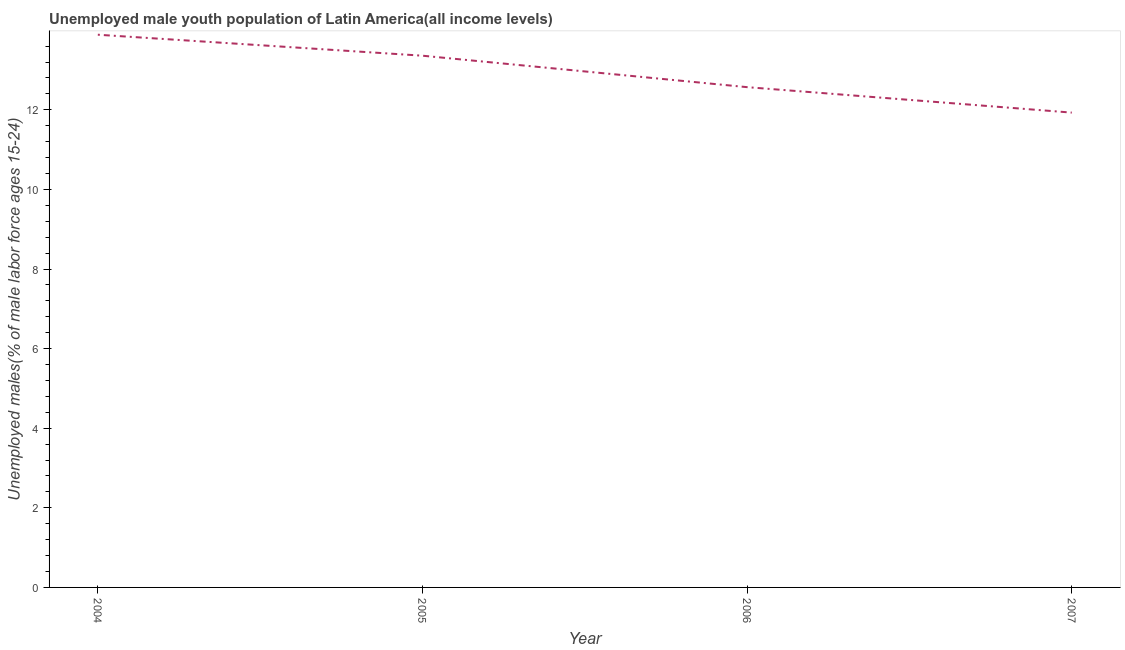What is the unemployed male youth in 2005?
Your answer should be very brief. 13.36. Across all years, what is the maximum unemployed male youth?
Your response must be concise. 13.89. Across all years, what is the minimum unemployed male youth?
Make the answer very short. 11.93. In which year was the unemployed male youth maximum?
Keep it short and to the point. 2004. What is the sum of the unemployed male youth?
Your answer should be compact. 51.74. What is the difference between the unemployed male youth in 2004 and 2007?
Ensure brevity in your answer.  1.96. What is the average unemployed male youth per year?
Your answer should be very brief. 12.94. What is the median unemployed male youth?
Offer a terse response. 12.96. Do a majority of the years between 2005 and 2007 (inclusive) have unemployed male youth greater than 1.6 %?
Your answer should be very brief. Yes. What is the ratio of the unemployed male youth in 2004 to that in 2006?
Ensure brevity in your answer.  1.1. Is the difference between the unemployed male youth in 2004 and 2007 greater than the difference between any two years?
Your answer should be compact. Yes. What is the difference between the highest and the second highest unemployed male youth?
Provide a succinct answer. 0.53. What is the difference between the highest and the lowest unemployed male youth?
Offer a very short reply. 1.96. In how many years, is the unemployed male youth greater than the average unemployed male youth taken over all years?
Offer a very short reply. 2. Does the unemployed male youth monotonically increase over the years?
Provide a short and direct response. No. How many lines are there?
Offer a very short reply. 1. How many years are there in the graph?
Your answer should be compact. 4. What is the difference between two consecutive major ticks on the Y-axis?
Give a very brief answer. 2. Does the graph contain any zero values?
Ensure brevity in your answer.  No. What is the title of the graph?
Offer a terse response. Unemployed male youth population of Latin America(all income levels). What is the label or title of the X-axis?
Your response must be concise. Year. What is the label or title of the Y-axis?
Keep it short and to the point. Unemployed males(% of male labor force ages 15-24). What is the Unemployed males(% of male labor force ages 15-24) in 2004?
Ensure brevity in your answer.  13.89. What is the Unemployed males(% of male labor force ages 15-24) of 2005?
Give a very brief answer. 13.36. What is the Unemployed males(% of male labor force ages 15-24) in 2006?
Provide a short and direct response. 12.57. What is the Unemployed males(% of male labor force ages 15-24) in 2007?
Your answer should be compact. 11.93. What is the difference between the Unemployed males(% of male labor force ages 15-24) in 2004 and 2005?
Your answer should be very brief. 0.53. What is the difference between the Unemployed males(% of male labor force ages 15-24) in 2004 and 2006?
Provide a short and direct response. 1.32. What is the difference between the Unemployed males(% of male labor force ages 15-24) in 2004 and 2007?
Provide a succinct answer. 1.96. What is the difference between the Unemployed males(% of male labor force ages 15-24) in 2005 and 2006?
Provide a short and direct response. 0.79. What is the difference between the Unemployed males(% of male labor force ages 15-24) in 2005 and 2007?
Make the answer very short. 1.43. What is the difference between the Unemployed males(% of male labor force ages 15-24) in 2006 and 2007?
Your answer should be compact. 0.64. What is the ratio of the Unemployed males(% of male labor force ages 15-24) in 2004 to that in 2005?
Offer a terse response. 1.04. What is the ratio of the Unemployed males(% of male labor force ages 15-24) in 2004 to that in 2006?
Your answer should be compact. 1.1. What is the ratio of the Unemployed males(% of male labor force ages 15-24) in 2004 to that in 2007?
Keep it short and to the point. 1.16. What is the ratio of the Unemployed males(% of male labor force ages 15-24) in 2005 to that in 2006?
Ensure brevity in your answer.  1.06. What is the ratio of the Unemployed males(% of male labor force ages 15-24) in 2005 to that in 2007?
Your answer should be compact. 1.12. What is the ratio of the Unemployed males(% of male labor force ages 15-24) in 2006 to that in 2007?
Offer a terse response. 1.05. 